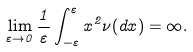<formula> <loc_0><loc_0><loc_500><loc_500>\lim _ { \varepsilon \rightarrow 0 } \frac { 1 } { \varepsilon } \int _ { - \varepsilon } ^ { \varepsilon } x ^ { 2 } \nu ( d x ) = \infty .</formula> 